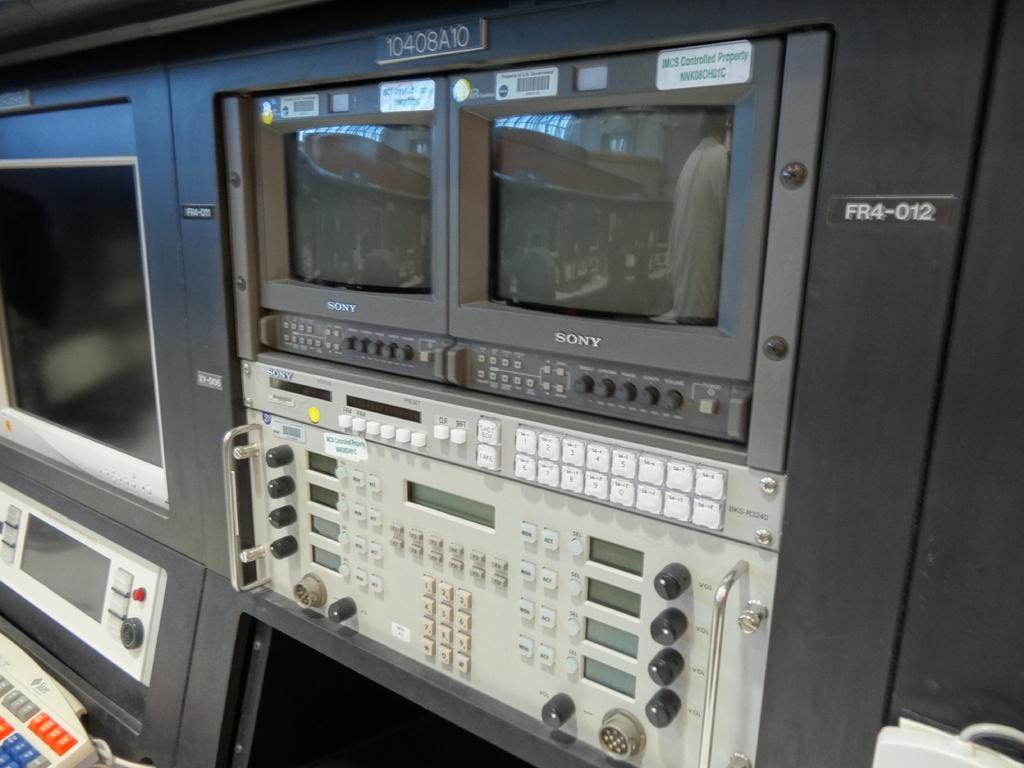<image>
Render a clear and concise summary of the photo. A pair of Sony branded monitors are stacked on top of a white machine. 